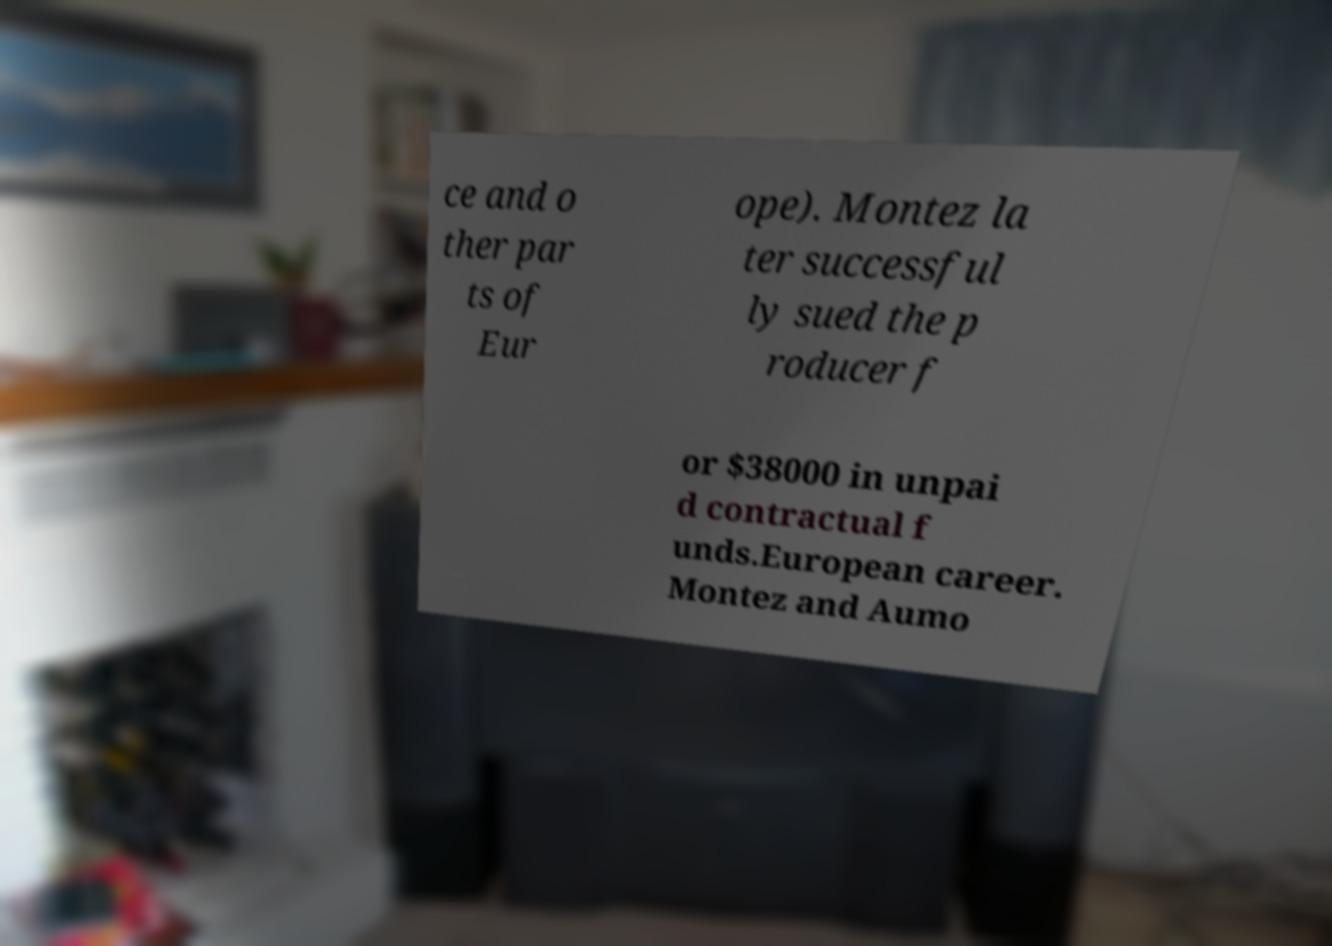Could you assist in decoding the text presented in this image and type it out clearly? ce and o ther par ts of Eur ope). Montez la ter successful ly sued the p roducer f or $38000 in unpai d contractual f unds.European career. Montez and Aumo 